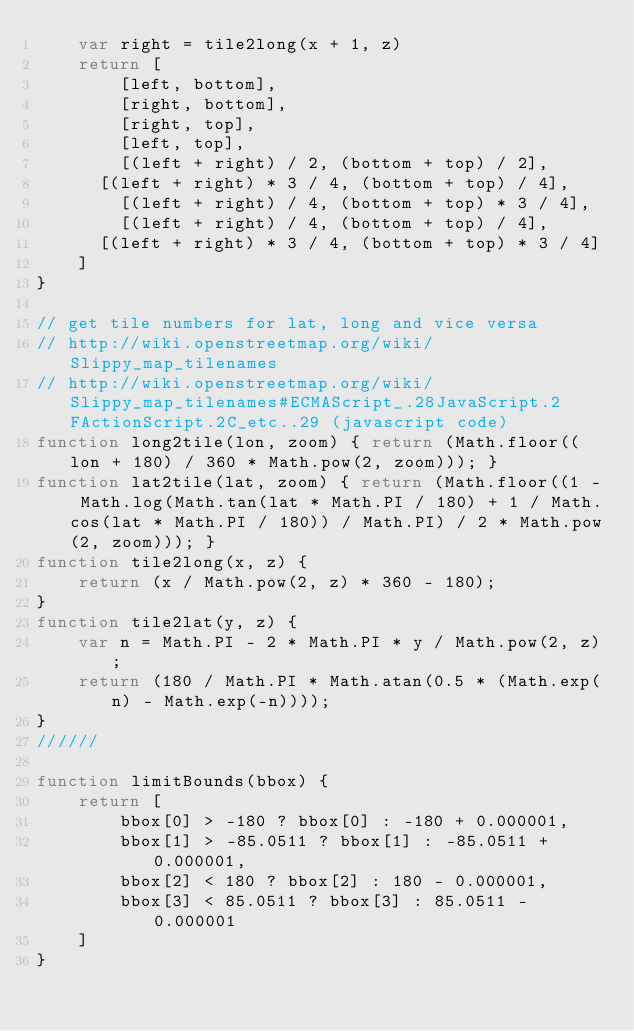<code> <loc_0><loc_0><loc_500><loc_500><_JavaScript_>    var right = tile2long(x + 1, z)
    return [
        [left, bottom],
        [right, bottom],
        [right, top],
        [left, top],
        [(left + right) / 2, (bottom + top) / 2],
	    [(left + right) * 3 / 4, (bottom + top) / 4],
        [(left + right) / 4, (bottom + top) * 3 / 4],
        [(left + right) / 4, (bottom + top) / 4],
	    [(left + right) * 3 / 4, (bottom + top) * 3 / 4]
    ]
}

// get tile numbers for lat, long and vice versa 
// http://wiki.openstreetmap.org/wiki/Slippy_map_tilenames 
// http://wiki.openstreetmap.org/wiki/Slippy_map_tilenames#ECMAScript_.28JavaScript.2FActionScript.2C_etc..29 (javascript code)
function long2tile(lon, zoom) { return (Math.floor((lon + 180) / 360 * Math.pow(2, zoom))); }
function lat2tile(lat, zoom) { return (Math.floor((1 - Math.log(Math.tan(lat * Math.PI / 180) + 1 / Math.cos(lat * Math.PI / 180)) / Math.PI) / 2 * Math.pow(2, zoom))); }
function tile2long(x, z) {
    return (x / Math.pow(2, z) * 360 - 180);
}
function tile2lat(y, z) {
    var n = Math.PI - 2 * Math.PI * y / Math.pow(2, z);
    return (180 / Math.PI * Math.atan(0.5 * (Math.exp(n) - Math.exp(-n))));
}
//////

function limitBounds(bbox) {
    return [
        bbox[0] > -180 ? bbox[0] : -180 + 0.000001,
        bbox[1] > -85.0511 ? bbox[1] : -85.0511 + 0.000001,
        bbox[2] < 180 ? bbox[2] : 180 - 0.000001,
        bbox[3] < 85.0511 ? bbox[3] : 85.0511 - 0.000001
    ]
}
</code> 